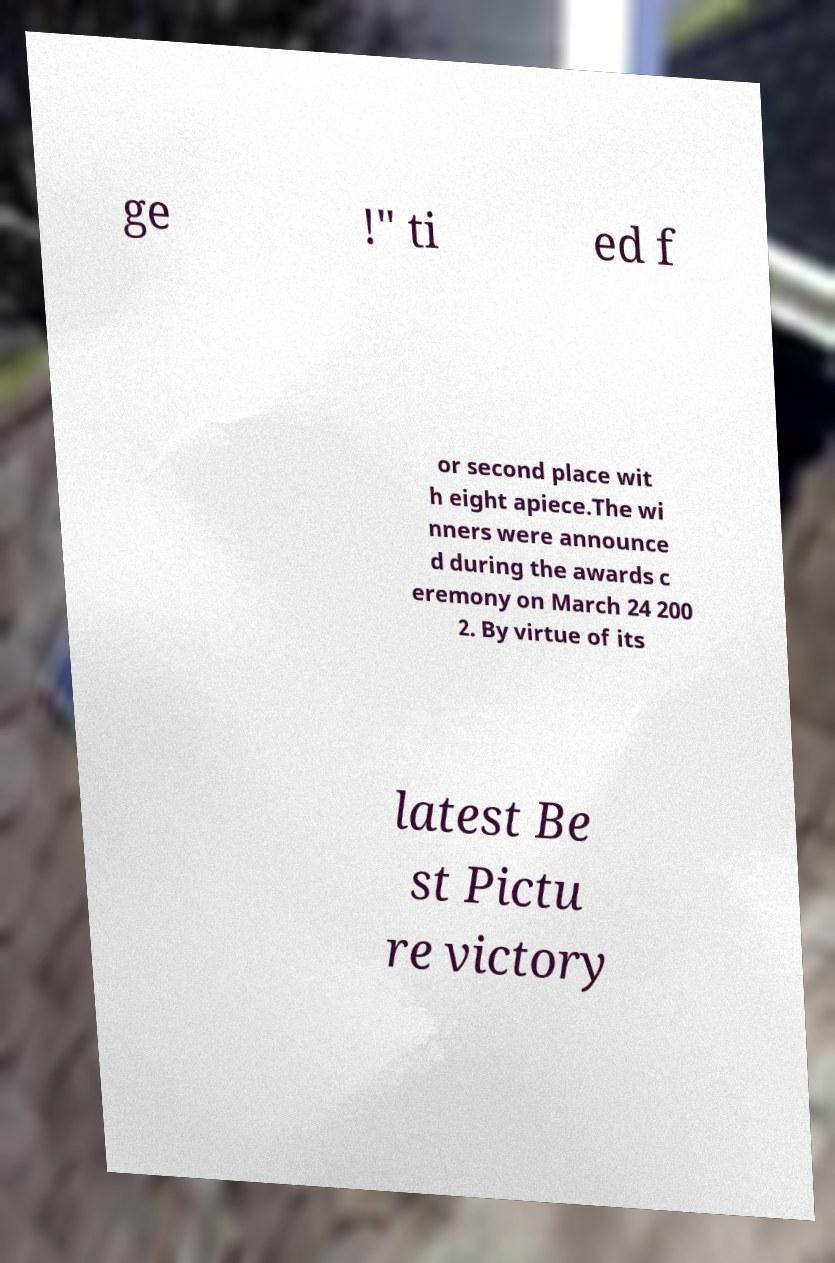For documentation purposes, I need the text within this image transcribed. Could you provide that? ge !" ti ed f or second place wit h eight apiece.The wi nners were announce d during the awards c eremony on March 24 200 2. By virtue of its latest Be st Pictu re victory 